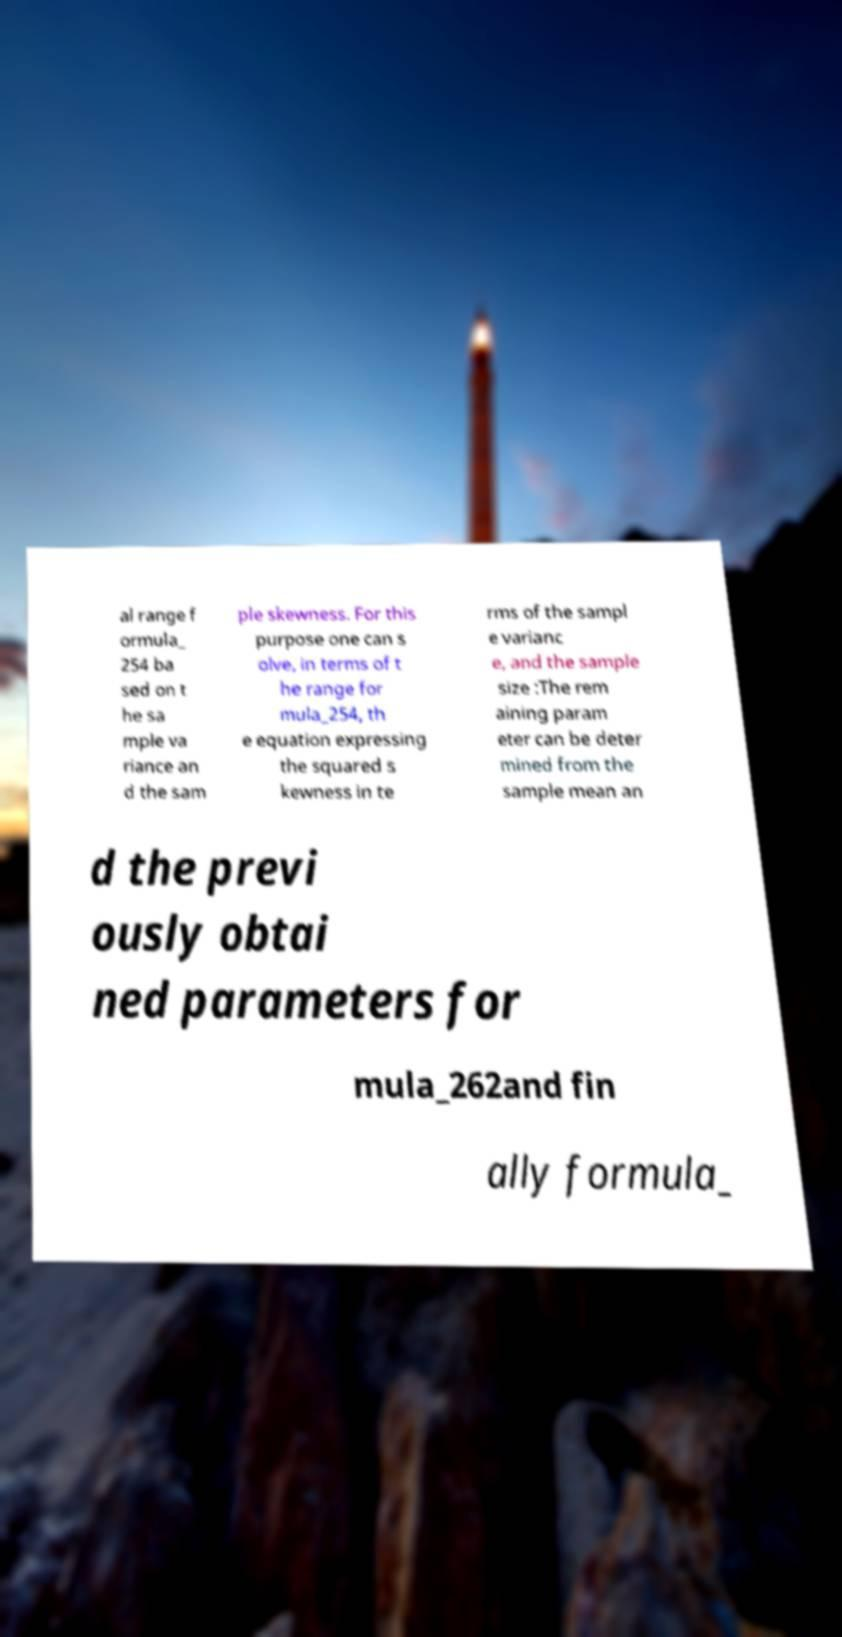What messages or text are displayed in this image? I need them in a readable, typed format. al range f ormula_ 254 ba sed on t he sa mple va riance an d the sam ple skewness. For this purpose one can s olve, in terms of t he range for mula_254, th e equation expressing the squared s kewness in te rms of the sampl e varianc e, and the sample size :The rem aining param eter can be deter mined from the sample mean an d the previ ously obtai ned parameters for mula_262and fin ally formula_ 